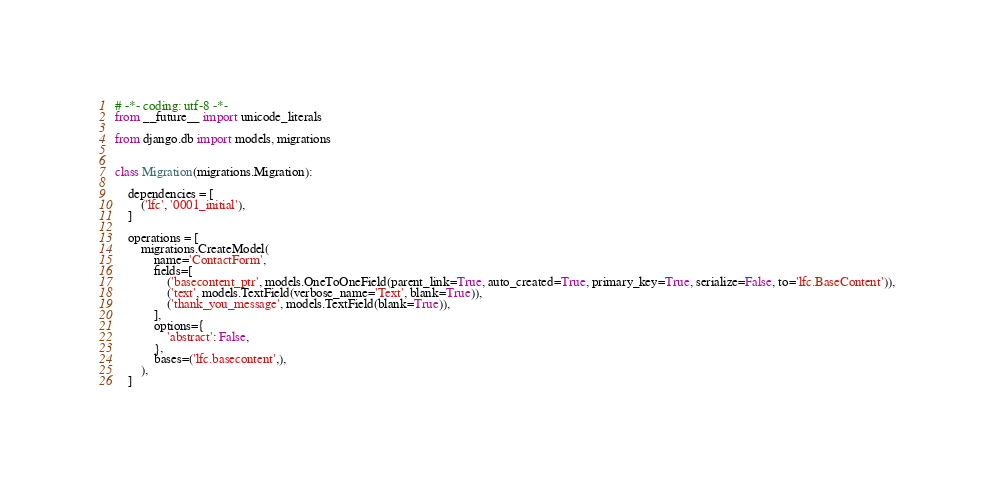Convert code to text. <code><loc_0><loc_0><loc_500><loc_500><_Python_># -*- coding: utf-8 -*-
from __future__ import unicode_literals

from django.db import models, migrations


class Migration(migrations.Migration):

    dependencies = [
        ('lfc', '0001_initial'),
    ]

    operations = [
        migrations.CreateModel(
            name='ContactForm',
            fields=[
                ('basecontent_ptr', models.OneToOneField(parent_link=True, auto_created=True, primary_key=True, serialize=False, to='lfc.BaseContent')),
                ('text', models.TextField(verbose_name='Text', blank=True)),
                ('thank_you_message', models.TextField(blank=True)),
            ],
            options={
                'abstract': False,
            },
            bases=('lfc.basecontent',),
        ),
    ]
</code> 